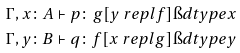<formula> <loc_0><loc_0><loc_500><loc_500>\Gamma , x \colon A & \vdash p \colon g [ y \ r e p l f ] \i d t y p e x \\ \Gamma , y \colon B & \vdash q \colon f [ x \ r e p l g ] \i d t y p e y</formula> 